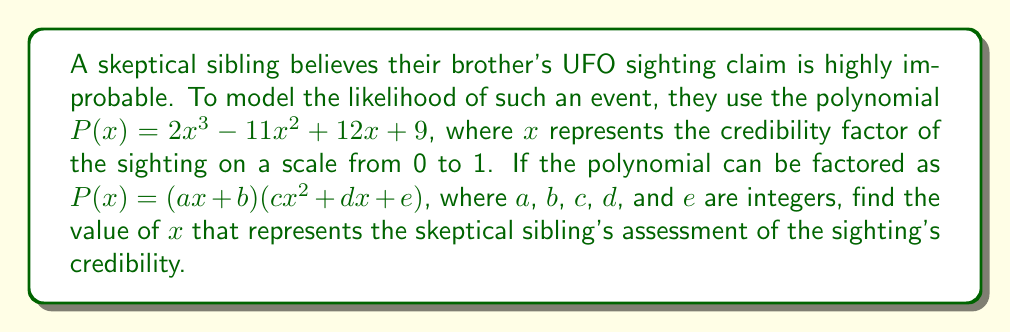Teach me how to tackle this problem. Let's approach this step-by-step:

1) First, we need to factor the polynomial $P(x) = 2x^3 - 11x^2 + 12x + 9$

2) We can start by looking for rational roots using the rational root theorem. The possible rational roots are the factors of the constant term (9): $\pm 1, \pm 3, \pm 9$

3) Testing these values, we find that $x = -1$ is a root of the polynomial.

4) This means $(x + 1)$ is a factor of $P(x)$

5) We can use polynomial long division to find the other factor:

   $2x^3 - 11x^2 + 12x + 9 = (x + 1)(2x^2 - 13x + 9)$

6) Now we have the factored form: $P(x) = (x + 1)(2x^2 - 13x + 9)$

7) Comparing this to the given form $(ax + b)(cx^2 + dx + e)$, we can see that:
   $a = 1$, $b = 1$, $c = 2$, $d = -13$, and $e = 9$

8) The question asks for the value of $x$ that represents the skeptical sibling's assessment. Given their skeptical nature, they would likely choose the smallest possible positive value of $x$.

9) The smallest positive value of $x$ that makes sense in this context is the smallest positive root of the polynomial.

10) We already know one root is $x = -1$, which is negative. The other roots can be found by solving $2x^2 - 13x + 9 = 0$

11) Using the quadratic formula: $x = \frac{13 \pm \sqrt{169 - 72}}{4} = \frac{13 \pm \sqrt{97}}{4}$

12) This gives us two more roots: $x \approx 0.5$ and $x \approx 6$

13) The smallest positive root is $x \approx 0.5$

Therefore, the skeptical sibling's assessment of the sighting's credibility is represented by $x \approx 0.5$.
Answer: $x \approx 0.5$ 